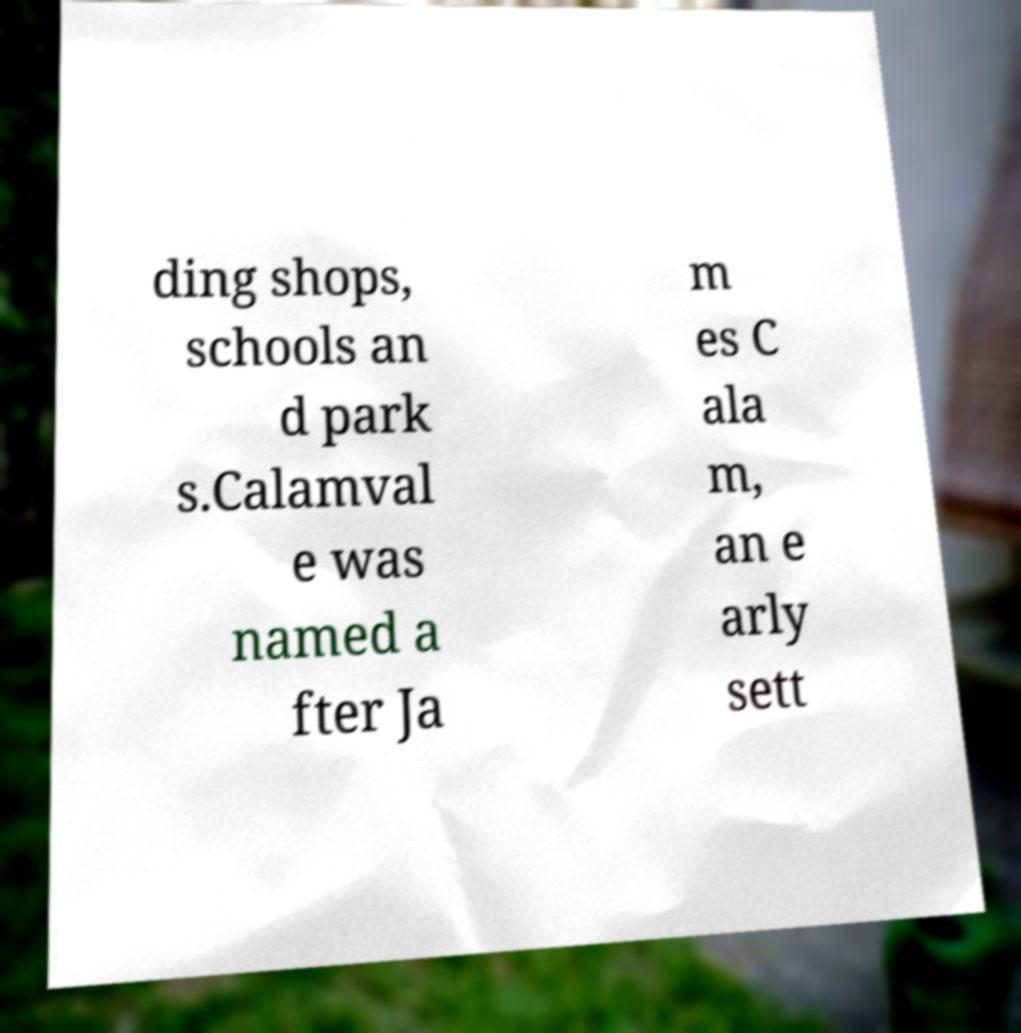Please identify and transcribe the text found in this image. ding shops, schools an d park s.Calamval e was named a fter Ja m es C ala m, an e arly sett 